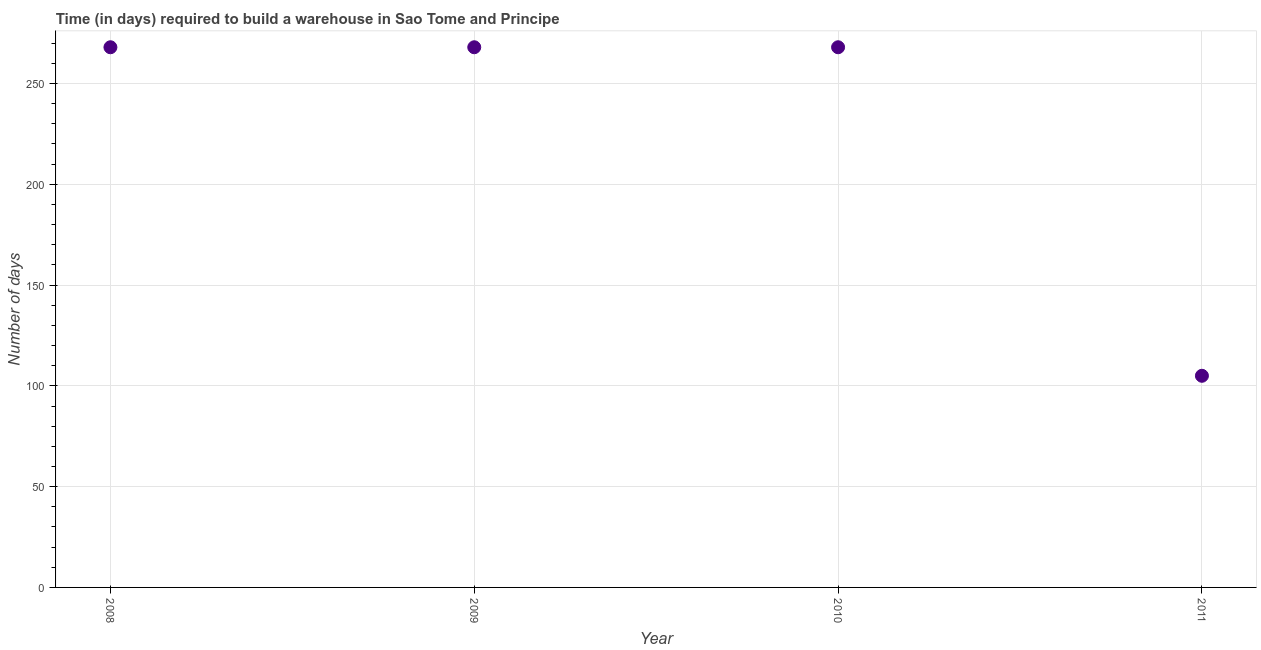What is the time required to build a warehouse in 2009?
Offer a very short reply. 268. Across all years, what is the maximum time required to build a warehouse?
Your response must be concise. 268. Across all years, what is the minimum time required to build a warehouse?
Keep it short and to the point. 105. In which year was the time required to build a warehouse maximum?
Offer a very short reply. 2008. What is the sum of the time required to build a warehouse?
Your answer should be compact. 909. What is the difference between the time required to build a warehouse in 2010 and 2011?
Your response must be concise. 163. What is the average time required to build a warehouse per year?
Offer a terse response. 227.25. What is the median time required to build a warehouse?
Your answer should be compact. 268. Do a majority of the years between 2010 and 2008 (inclusive) have time required to build a warehouse greater than 210 days?
Keep it short and to the point. No. Is the time required to build a warehouse in 2010 less than that in 2011?
Make the answer very short. No. Is the difference between the time required to build a warehouse in 2009 and 2010 greater than the difference between any two years?
Your answer should be compact. No. What is the difference between the highest and the second highest time required to build a warehouse?
Your answer should be very brief. 0. What is the difference between the highest and the lowest time required to build a warehouse?
Your answer should be very brief. 163. Does the time required to build a warehouse monotonically increase over the years?
Keep it short and to the point. No. How many dotlines are there?
Ensure brevity in your answer.  1. How many years are there in the graph?
Keep it short and to the point. 4. Does the graph contain any zero values?
Provide a succinct answer. No. Does the graph contain grids?
Provide a short and direct response. Yes. What is the title of the graph?
Ensure brevity in your answer.  Time (in days) required to build a warehouse in Sao Tome and Principe. What is the label or title of the X-axis?
Your answer should be very brief. Year. What is the label or title of the Y-axis?
Provide a short and direct response. Number of days. What is the Number of days in 2008?
Provide a succinct answer. 268. What is the Number of days in 2009?
Make the answer very short. 268. What is the Number of days in 2010?
Give a very brief answer. 268. What is the Number of days in 2011?
Give a very brief answer. 105. What is the difference between the Number of days in 2008 and 2010?
Keep it short and to the point. 0. What is the difference between the Number of days in 2008 and 2011?
Offer a very short reply. 163. What is the difference between the Number of days in 2009 and 2010?
Your response must be concise. 0. What is the difference between the Number of days in 2009 and 2011?
Keep it short and to the point. 163. What is the difference between the Number of days in 2010 and 2011?
Give a very brief answer. 163. What is the ratio of the Number of days in 2008 to that in 2009?
Provide a short and direct response. 1. What is the ratio of the Number of days in 2008 to that in 2011?
Make the answer very short. 2.55. What is the ratio of the Number of days in 2009 to that in 2011?
Your answer should be compact. 2.55. What is the ratio of the Number of days in 2010 to that in 2011?
Your answer should be compact. 2.55. 